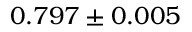Convert formula to latex. <formula><loc_0><loc_0><loc_500><loc_500>0 . 7 9 7 \pm 0 . 0 0 5</formula> 